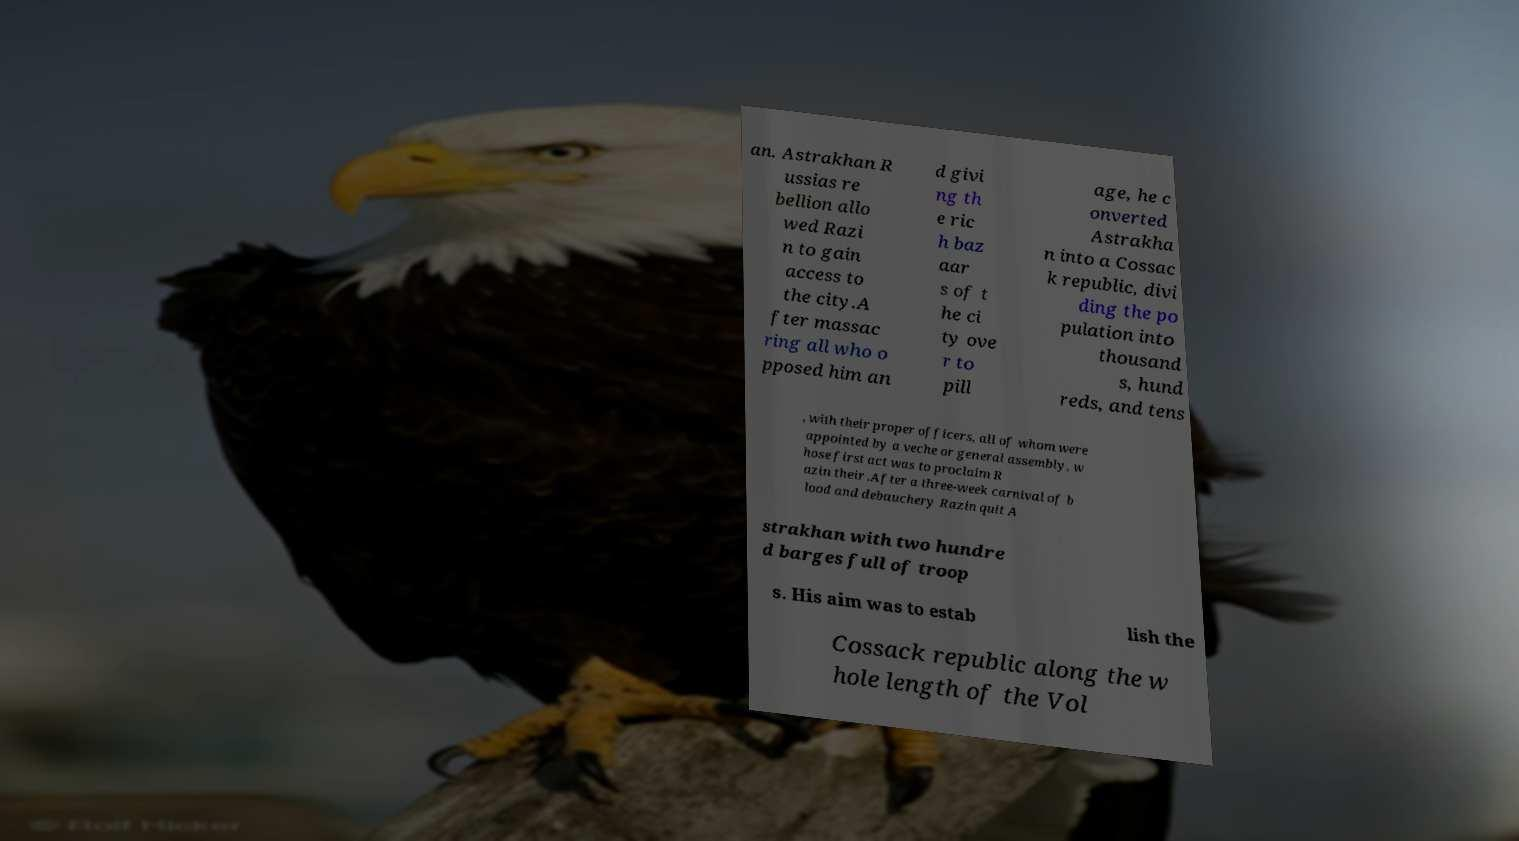Could you assist in decoding the text presented in this image and type it out clearly? an. Astrakhan R ussias re bellion allo wed Razi n to gain access to the city.A fter massac ring all who o pposed him an d givi ng th e ric h baz aar s of t he ci ty ove r to pill age, he c onverted Astrakha n into a Cossac k republic, divi ding the po pulation into thousand s, hund reds, and tens , with their proper officers, all of whom were appointed by a veche or general assembly, w hose first act was to proclaim R azin their .After a three-week carnival of b lood and debauchery Razin quit A strakhan with two hundre d barges full of troop s. His aim was to estab lish the Cossack republic along the w hole length of the Vol 